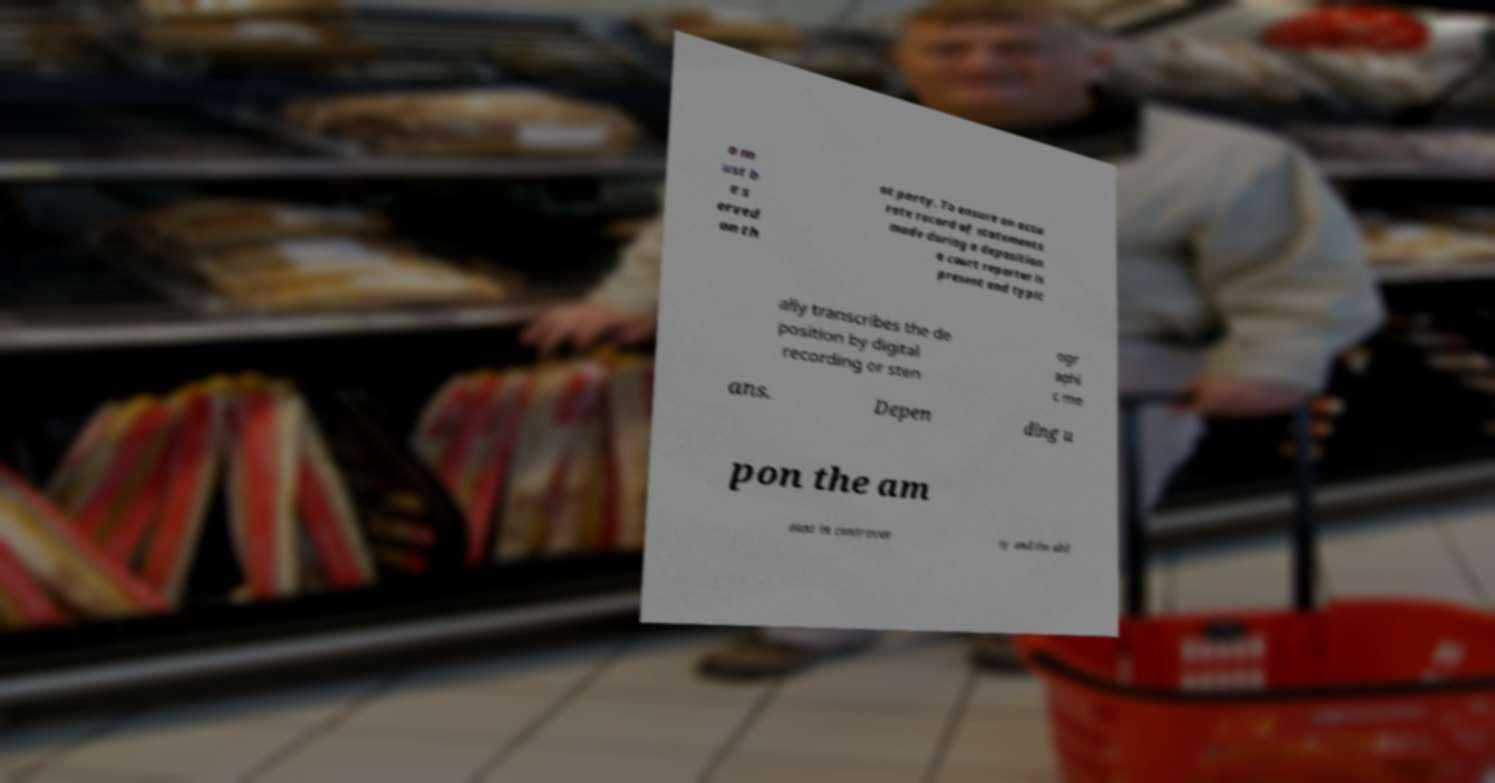Could you extract and type out the text from this image? a m ust b e s erved on th at party. To ensure an accu rate record of statements made during a deposition a court reporter is present and typic ally transcribes the de position by digital recording or sten ogr aphi c me ans. Depen ding u pon the am ount in controver sy and the abil 